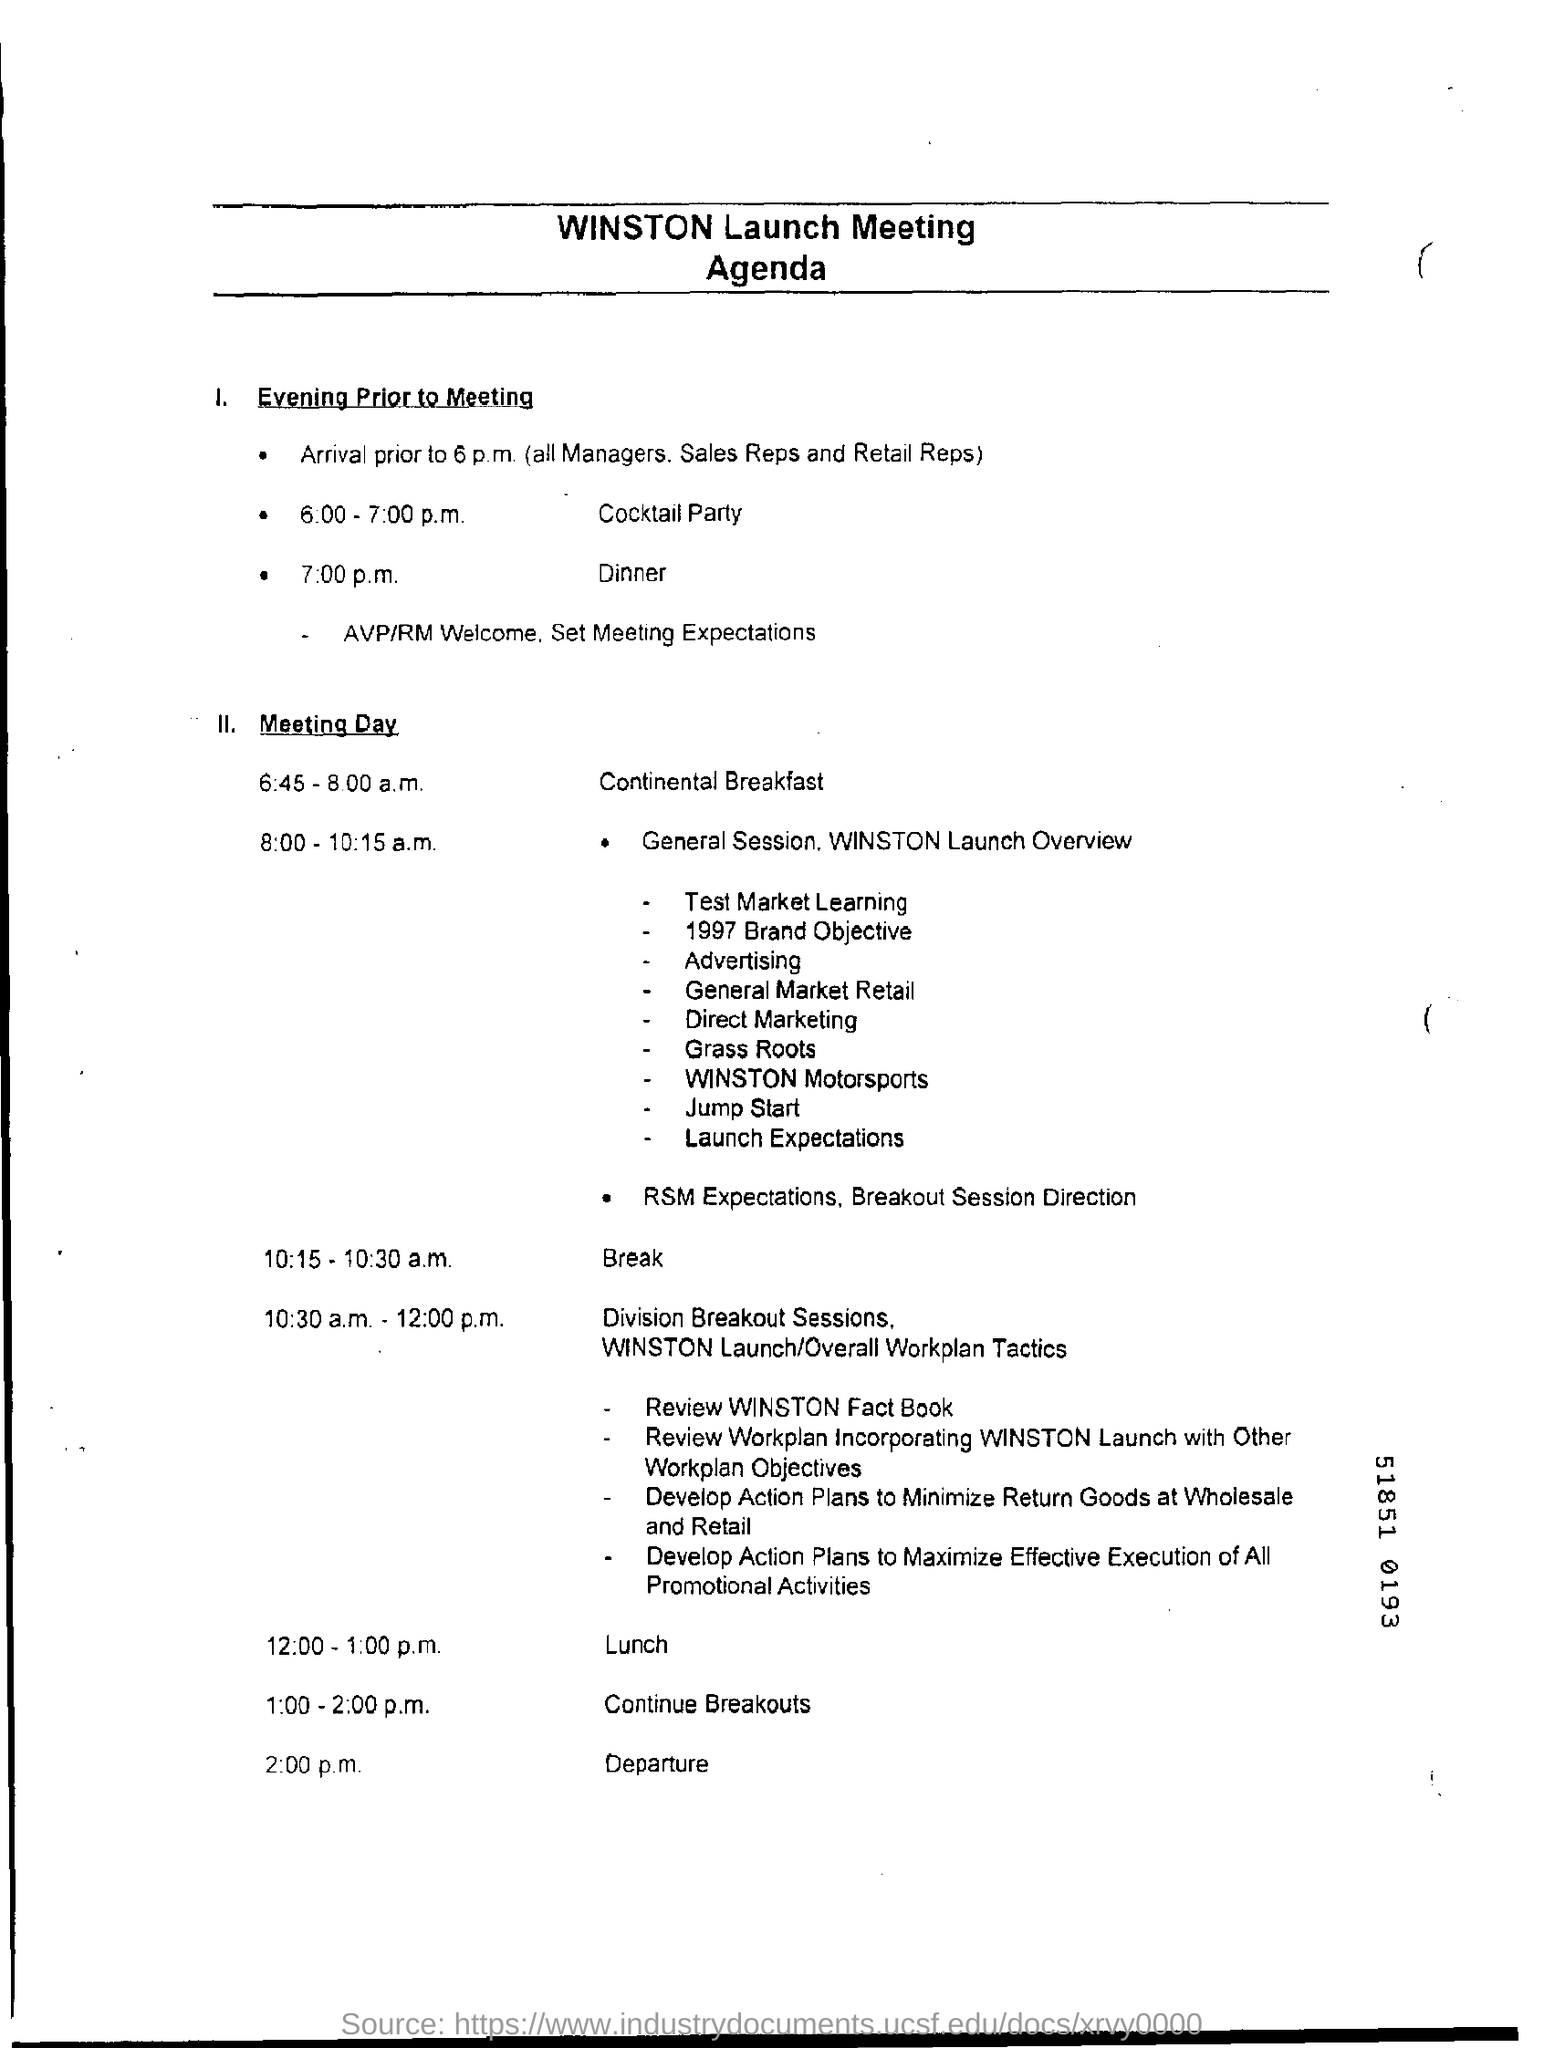When is the cocktail party scheduled on the evening prior to the meeting?
Give a very brief answer. 6.00- 7:00 p.m. When is the departure?
Your response must be concise. 2:00 p.m. 